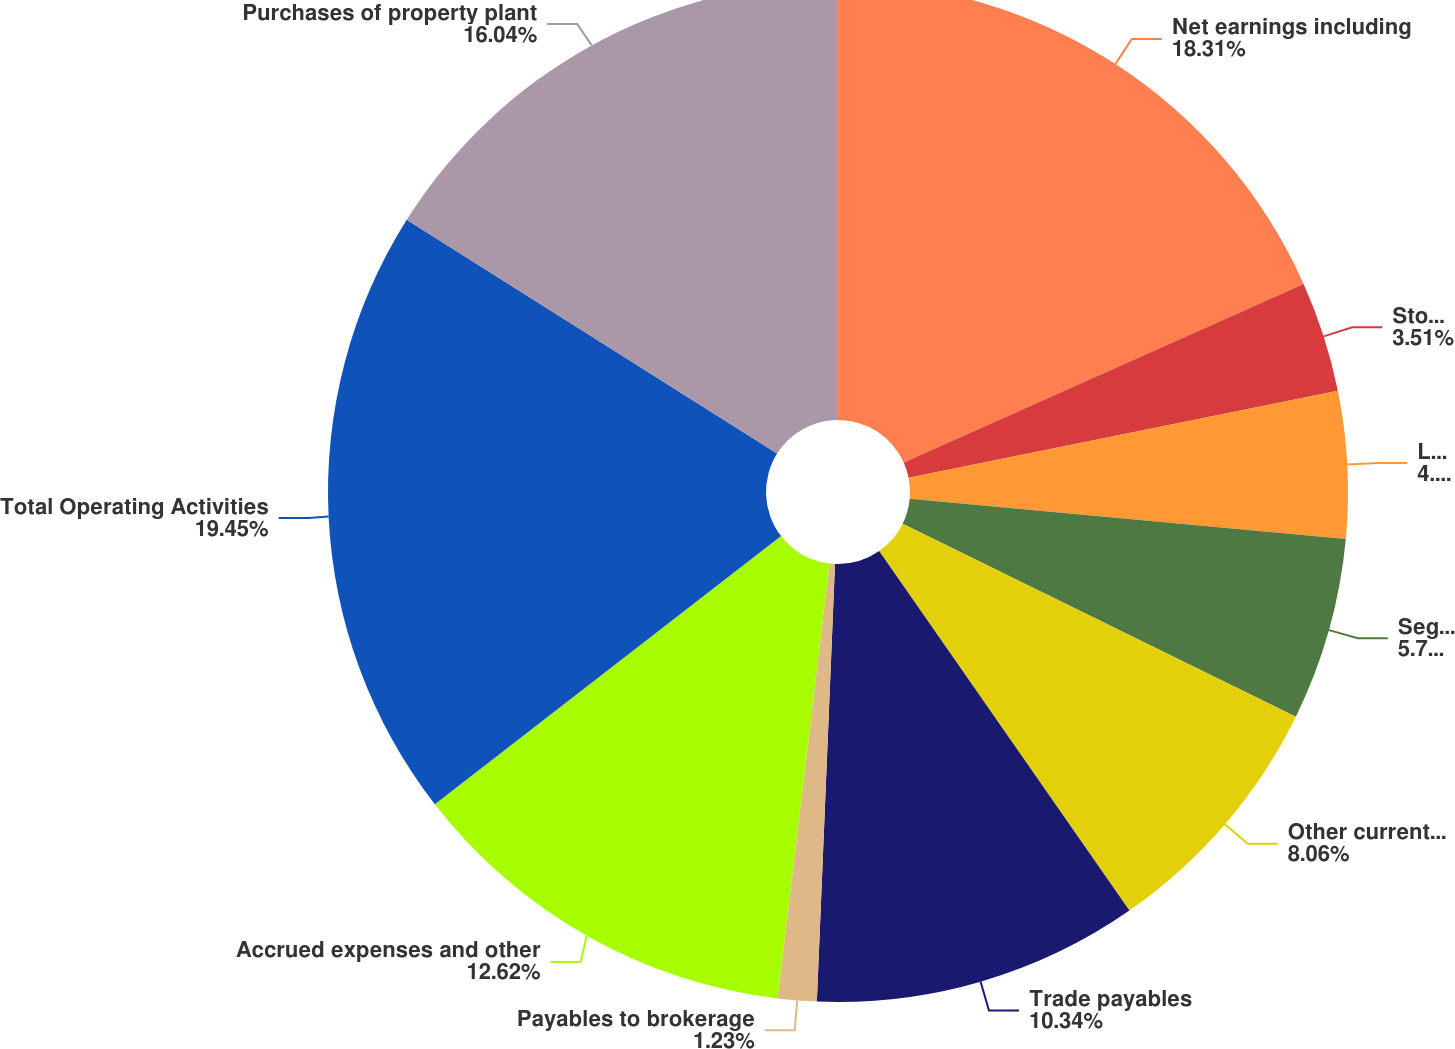Convert chart. <chart><loc_0><loc_0><loc_500><loc_500><pie_chart><fcel>Net earnings including<fcel>Stock compensation expense<fcel>Loss on debt extinguishment<fcel>Segregated cash and<fcel>Other current assets<fcel>Trade payables<fcel>Payables to brokerage<fcel>Accrued expenses and other<fcel>Total Operating Activities<fcel>Purchases of property plant<nl><fcel>18.31%<fcel>3.51%<fcel>4.65%<fcel>5.79%<fcel>8.06%<fcel>10.34%<fcel>1.23%<fcel>12.62%<fcel>19.45%<fcel>16.04%<nl></chart> 